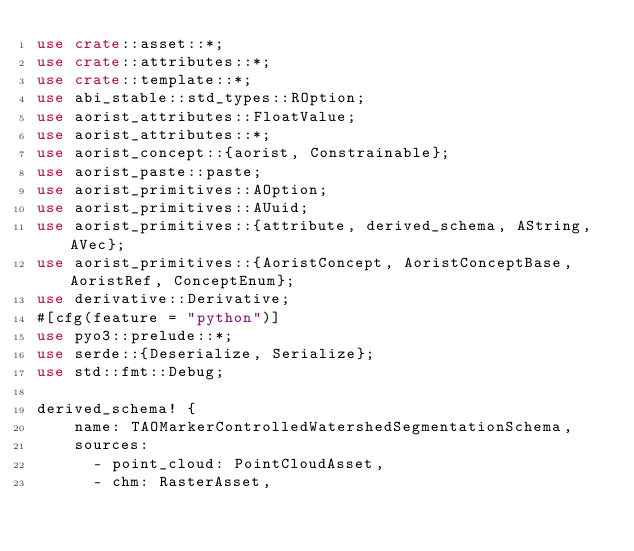<code> <loc_0><loc_0><loc_500><loc_500><_Rust_>use crate::asset::*;
use crate::attributes::*;
use crate::template::*;
use abi_stable::std_types::ROption;
use aorist_attributes::FloatValue;
use aorist_attributes::*;
use aorist_concept::{aorist, Constrainable};
use aorist_paste::paste;
use aorist_primitives::AOption;
use aorist_primitives::AUuid;
use aorist_primitives::{attribute, derived_schema, AString, AVec};
use aorist_primitives::{AoristConcept, AoristConceptBase, AoristRef, ConceptEnum};
use derivative::Derivative;
#[cfg(feature = "python")]
use pyo3::prelude::*;
use serde::{Deserialize, Serialize};
use std::fmt::Debug;

derived_schema! {
    name: TAOMarkerControlledWatershedSegmentationSchema,
    sources:
      - point_cloud: PointCloudAsset,
      - chm: RasterAsset,</code> 